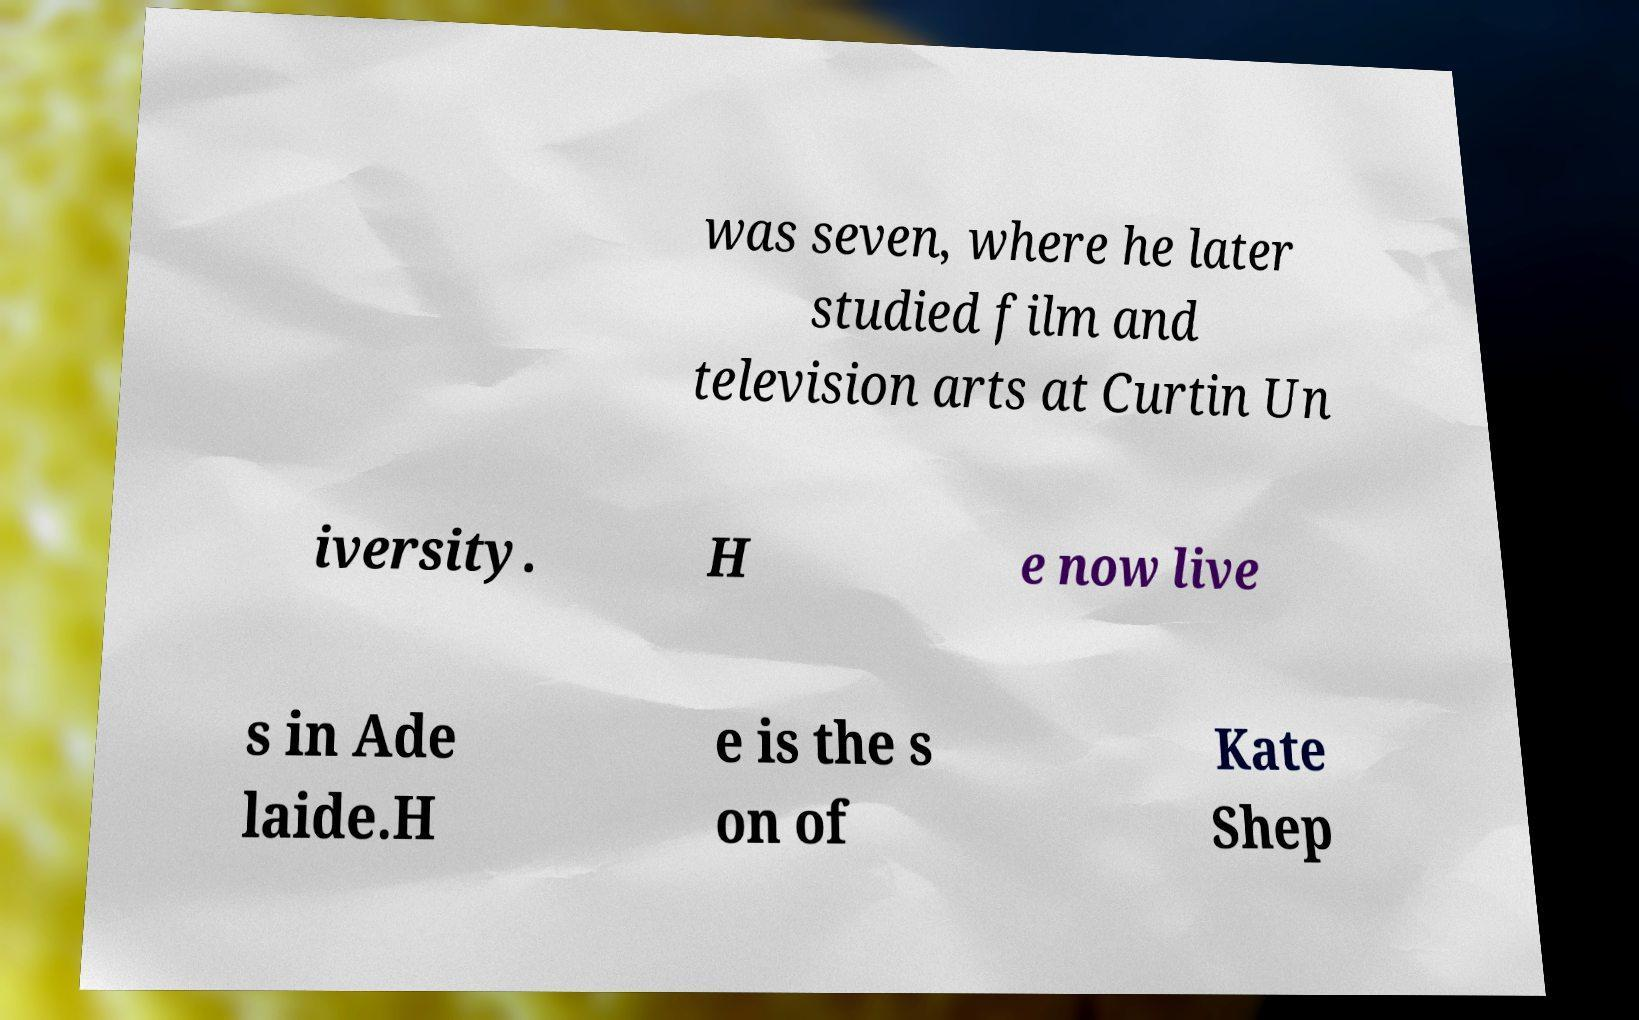Can you read and provide the text displayed in the image?This photo seems to have some interesting text. Can you extract and type it out for me? was seven, where he later studied film and television arts at Curtin Un iversity. H e now live s in Ade laide.H e is the s on of Kate Shep 